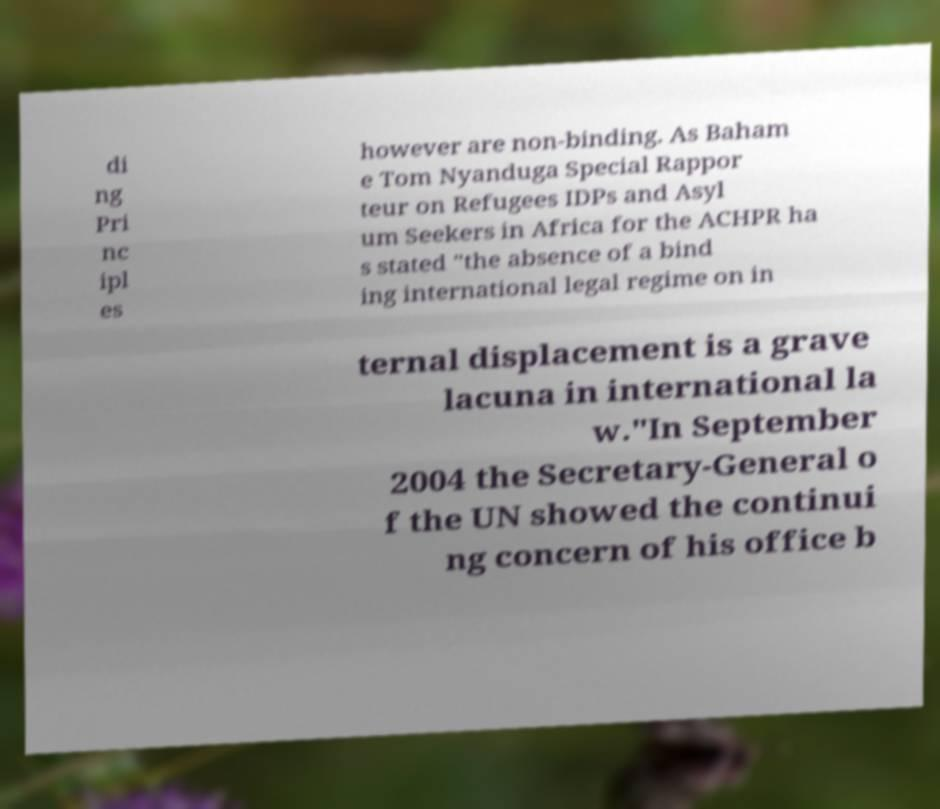There's text embedded in this image that I need extracted. Can you transcribe it verbatim? di ng Pri nc ipl es however are non-binding. As Baham e Tom Nyanduga Special Rappor teur on Refugees IDPs and Asyl um Seekers in Africa for the ACHPR ha s stated "the absence of a bind ing international legal regime on in ternal displacement is a grave lacuna in international la w."In September 2004 the Secretary-General o f the UN showed the continui ng concern of his office b 